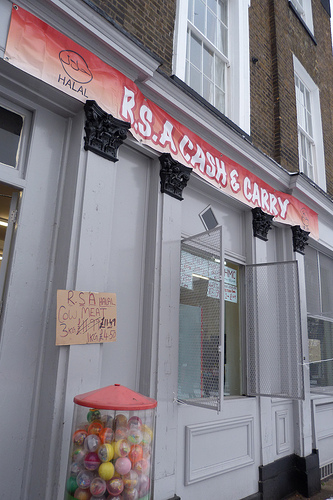<image>
Is there a sign behind the sill? Yes. From this viewpoint, the sign is positioned behind the sill, with the sill partially or fully occluding the sign. 